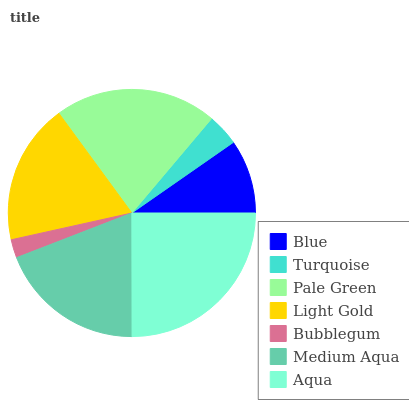Is Bubblegum the minimum?
Answer yes or no. Yes. Is Aqua the maximum?
Answer yes or no. Yes. Is Turquoise the minimum?
Answer yes or no. No. Is Turquoise the maximum?
Answer yes or no. No. Is Blue greater than Turquoise?
Answer yes or no. Yes. Is Turquoise less than Blue?
Answer yes or no. Yes. Is Turquoise greater than Blue?
Answer yes or no. No. Is Blue less than Turquoise?
Answer yes or no. No. Is Light Gold the high median?
Answer yes or no. Yes. Is Light Gold the low median?
Answer yes or no. Yes. Is Aqua the high median?
Answer yes or no. No. Is Blue the low median?
Answer yes or no. No. 